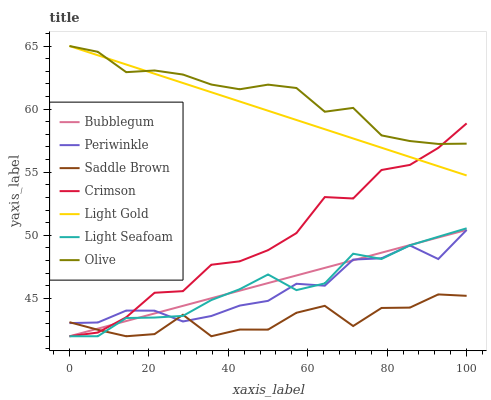Does Saddle Brown have the minimum area under the curve?
Answer yes or no. Yes. Does Olive have the maximum area under the curve?
Answer yes or no. Yes. Does Periwinkle have the minimum area under the curve?
Answer yes or no. No. Does Periwinkle have the maximum area under the curve?
Answer yes or no. No. Is Bubblegum the smoothest?
Answer yes or no. Yes. Is Saddle Brown the roughest?
Answer yes or no. Yes. Is Olive the smoothest?
Answer yes or no. No. Is Olive the roughest?
Answer yes or no. No. Does Bubblegum have the lowest value?
Answer yes or no. Yes. Does Periwinkle have the lowest value?
Answer yes or no. No. Does Light Gold have the highest value?
Answer yes or no. Yes. Does Periwinkle have the highest value?
Answer yes or no. No. Is Bubblegum less than Light Gold?
Answer yes or no. Yes. Is Olive greater than Saddle Brown?
Answer yes or no. Yes. Does Bubblegum intersect Light Seafoam?
Answer yes or no. Yes. Is Bubblegum less than Light Seafoam?
Answer yes or no. No. Is Bubblegum greater than Light Seafoam?
Answer yes or no. No. Does Bubblegum intersect Light Gold?
Answer yes or no. No. 